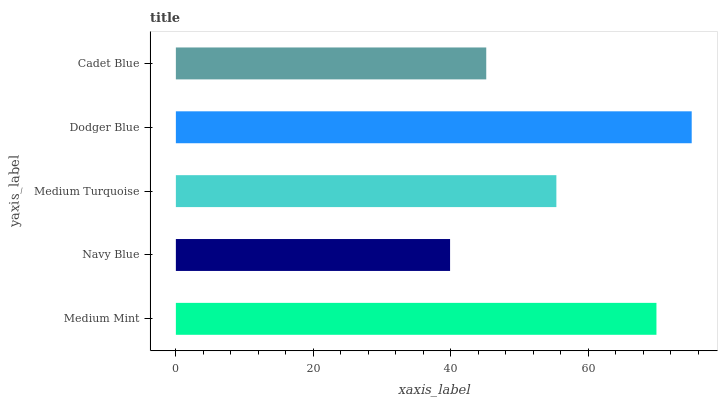Is Navy Blue the minimum?
Answer yes or no. Yes. Is Dodger Blue the maximum?
Answer yes or no. Yes. Is Medium Turquoise the minimum?
Answer yes or no. No. Is Medium Turquoise the maximum?
Answer yes or no. No. Is Medium Turquoise greater than Navy Blue?
Answer yes or no. Yes. Is Navy Blue less than Medium Turquoise?
Answer yes or no. Yes. Is Navy Blue greater than Medium Turquoise?
Answer yes or no. No. Is Medium Turquoise less than Navy Blue?
Answer yes or no. No. Is Medium Turquoise the high median?
Answer yes or no. Yes. Is Medium Turquoise the low median?
Answer yes or no. Yes. Is Dodger Blue the high median?
Answer yes or no. No. Is Cadet Blue the low median?
Answer yes or no. No. 